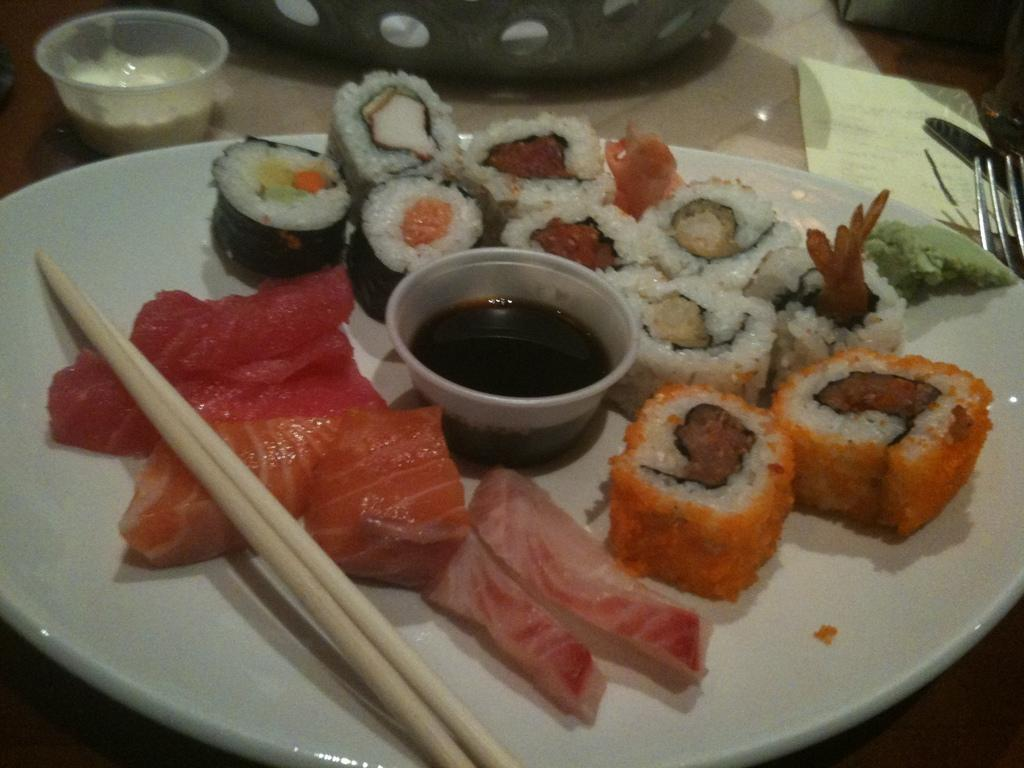What type of objects can be seen in the image? There are food items in the image. Where are the food items placed? The food items are kept on a table. What utensil is present in the image? Chopsticks are in the image. What type of whistle is being used to punish the crown in the image? There is no whistle, punishment, or crown present in the image. 